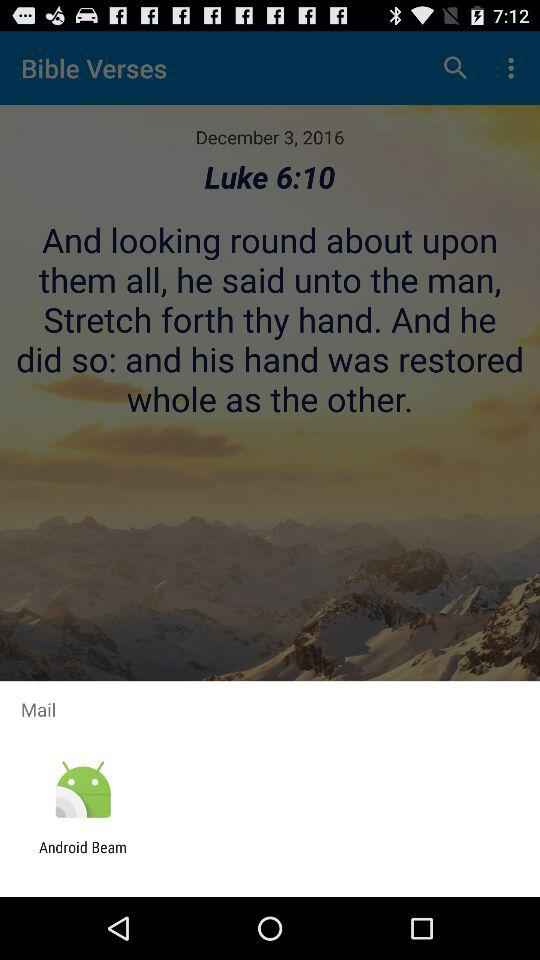What is the option for mailing? The option for mailing is "Android Beam". 